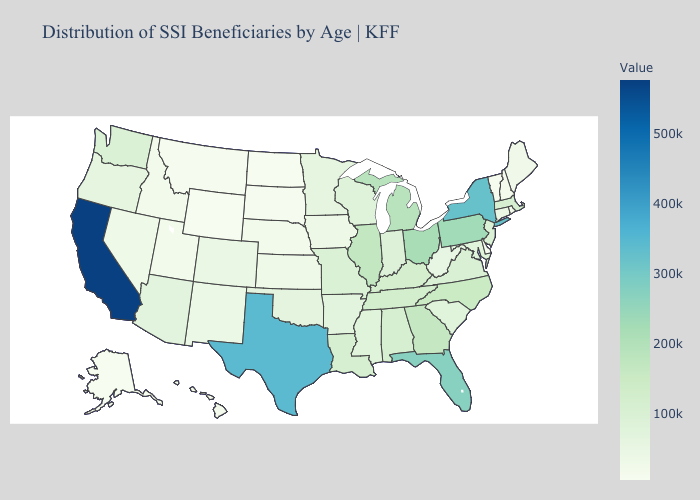Does New York have the highest value in the USA?
Short answer required. No. Does Connecticut have the highest value in the Northeast?
Quick response, please. No. Among the states that border Texas , does Louisiana have the highest value?
Concise answer only. Yes. Is the legend a continuous bar?
Answer briefly. Yes. Does Mississippi have a lower value than Wyoming?
Give a very brief answer. No. Does South Carolina have a higher value than Alaska?
Answer briefly. Yes. Does California have the highest value in the West?
Short answer required. Yes. Does Connecticut have the highest value in the Northeast?
Answer briefly. No. 